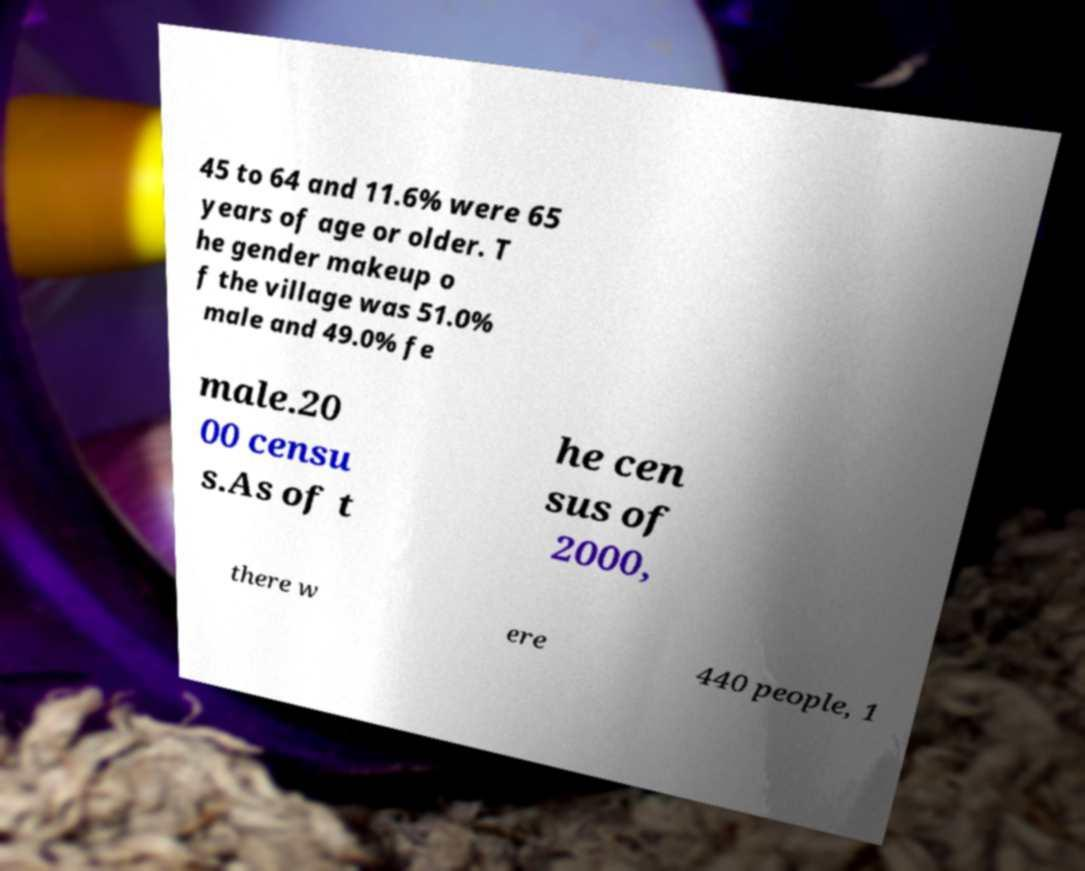There's text embedded in this image that I need extracted. Can you transcribe it verbatim? 45 to 64 and 11.6% were 65 years of age or older. T he gender makeup o f the village was 51.0% male and 49.0% fe male.20 00 censu s.As of t he cen sus of 2000, there w ere 440 people, 1 